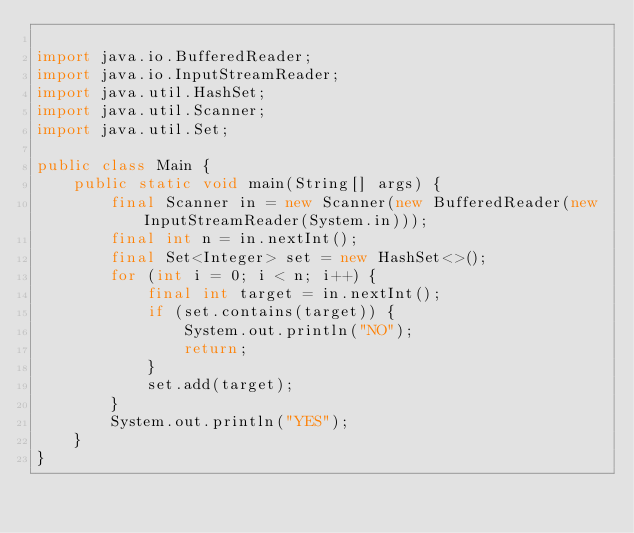<code> <loc_0><loc_0><loc_500><loc_500><_Java_>
import java.io.BufferedReader;
import java.io.InputStreamReader;
import java.util.HashSet;
import java.util.Scanner;
import java.util.Set;

public class Main {
    public static void main(String[] args) {
        final Scanner in = new Scanner(new BufferedReader(new InputStreamReader(System.in)));
        final int n = in.nextInt();
        final Set<Integer> set = new HashSet<>();
        for (int i = 0; i < n; i++) {
            final int target = in.nextInt();
            if (set.contains(target)) {
                System.out.println("NO");
                return;
            }
            set.add(target);
        }
        System.out.println("YES");
    }
}
</code> 